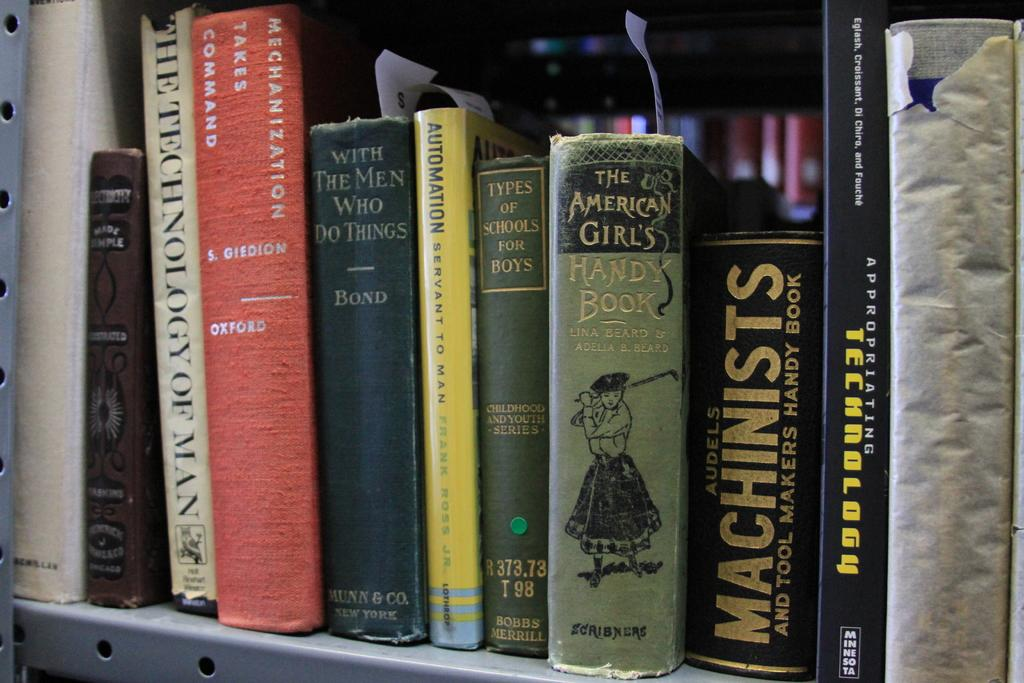<image>
Write a terse but informative summary of the picture. A machinists book is on a shelf with other books. 